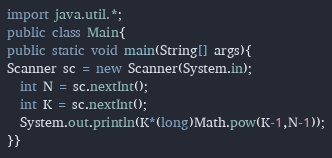Convert code to text. <code><loc_0><loc_0><loc_500><loc_500><_Java_>import java.util.*;
public class Main{
public static void main(String[] args){
Scanner sc = new Scanner(System.in);
  int N = sc.nextInt();
  int K = sc.nextInt();
  System.out.println(K*(long)Math.pow(K-1,N-1));
}}
</code> 